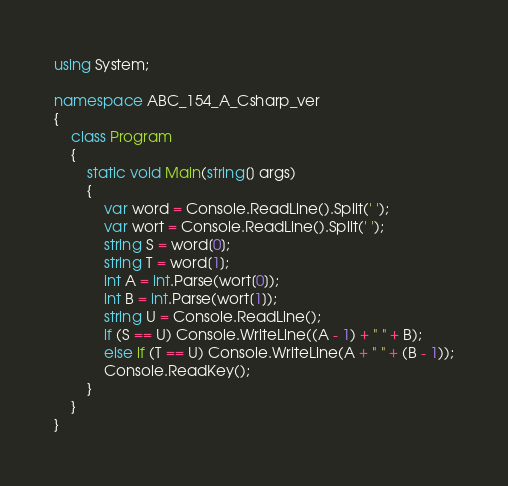<code> <loc_0><loc_0><loc_500><loc_500><_C#_>using System;

namespace ABC_154_A_Csharp_ver
{
    class Program
    {
        static void Main(string[] args)
        {
            var word = Console.ReadLine().Split(' ');
            var wort = Console.ReadLine().Split(' ');
            string S = word[0];
            string T = word[1];
            int A = int.Parse(wort[0]);
            int B = int.Parse(wort[1]);
            string U = Console.ReadLine();
            if (S == U) Console.WriteLine((A - 1) + " " + B);
            else if (T == U) Console.WriteLine(A + " " + (B - 1));
            Console.ReadKey();
        }
    }
}
</code> 